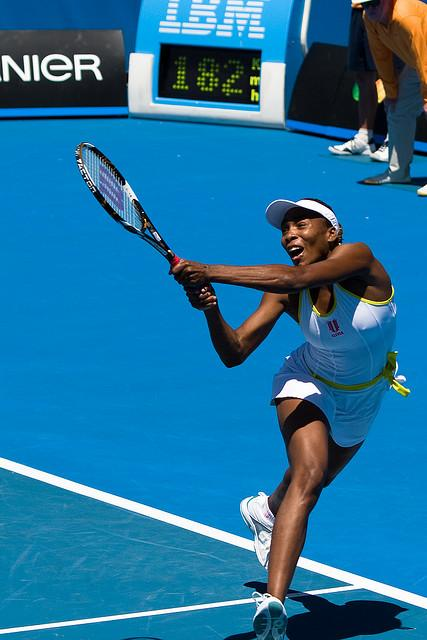What is her sister's name? Please explain your reasoning. serena. Venus is the sister to serena. 